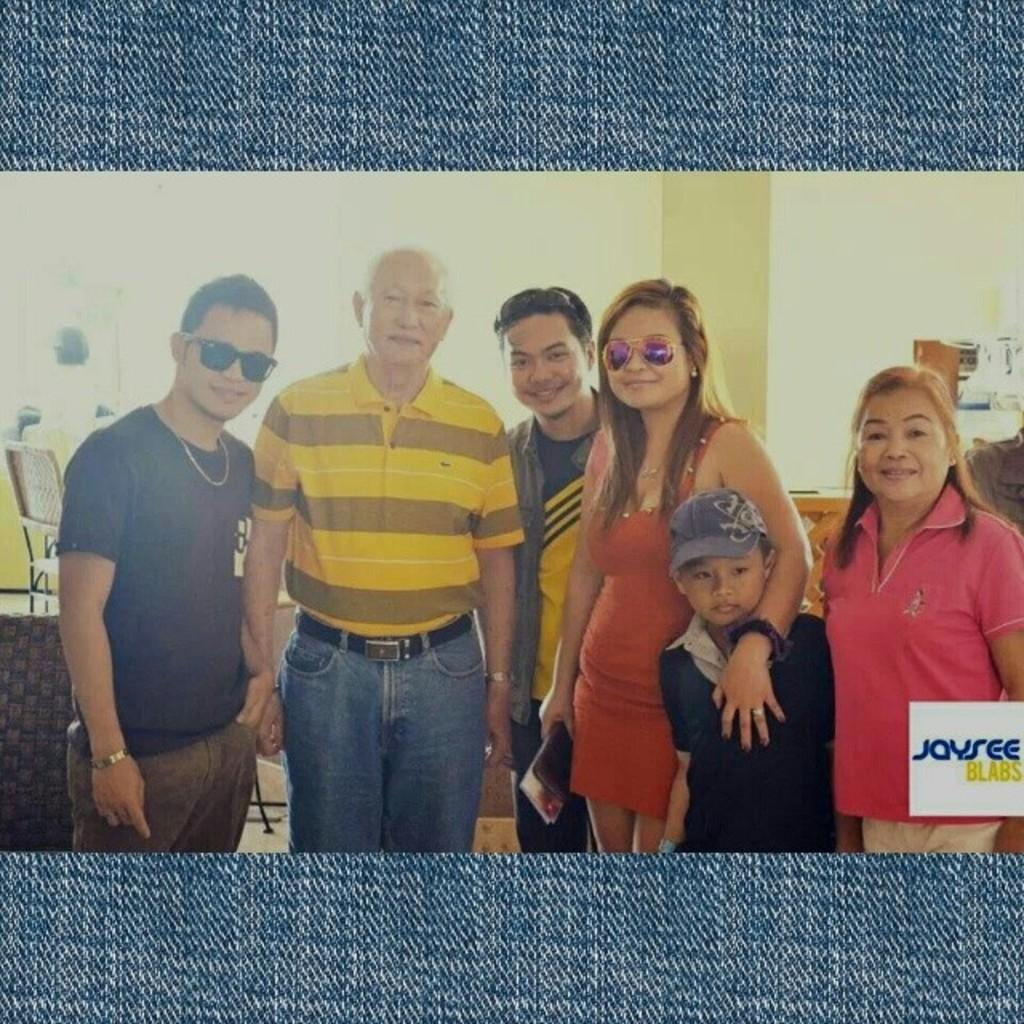How was the image altered or modified? The image is edited. What can be seen in the distance behind the people? There is a wall in the background of the image, along with many other objects. What is happening in the foreground of the image? There are people standing in the middle of the image. What is the emotional expression of the people in the image? The people have smiling faces. What type of crate is being used to store the people's desires in the image? There is no crate or mention of desires in the image; it features people standing with smiling faces. 